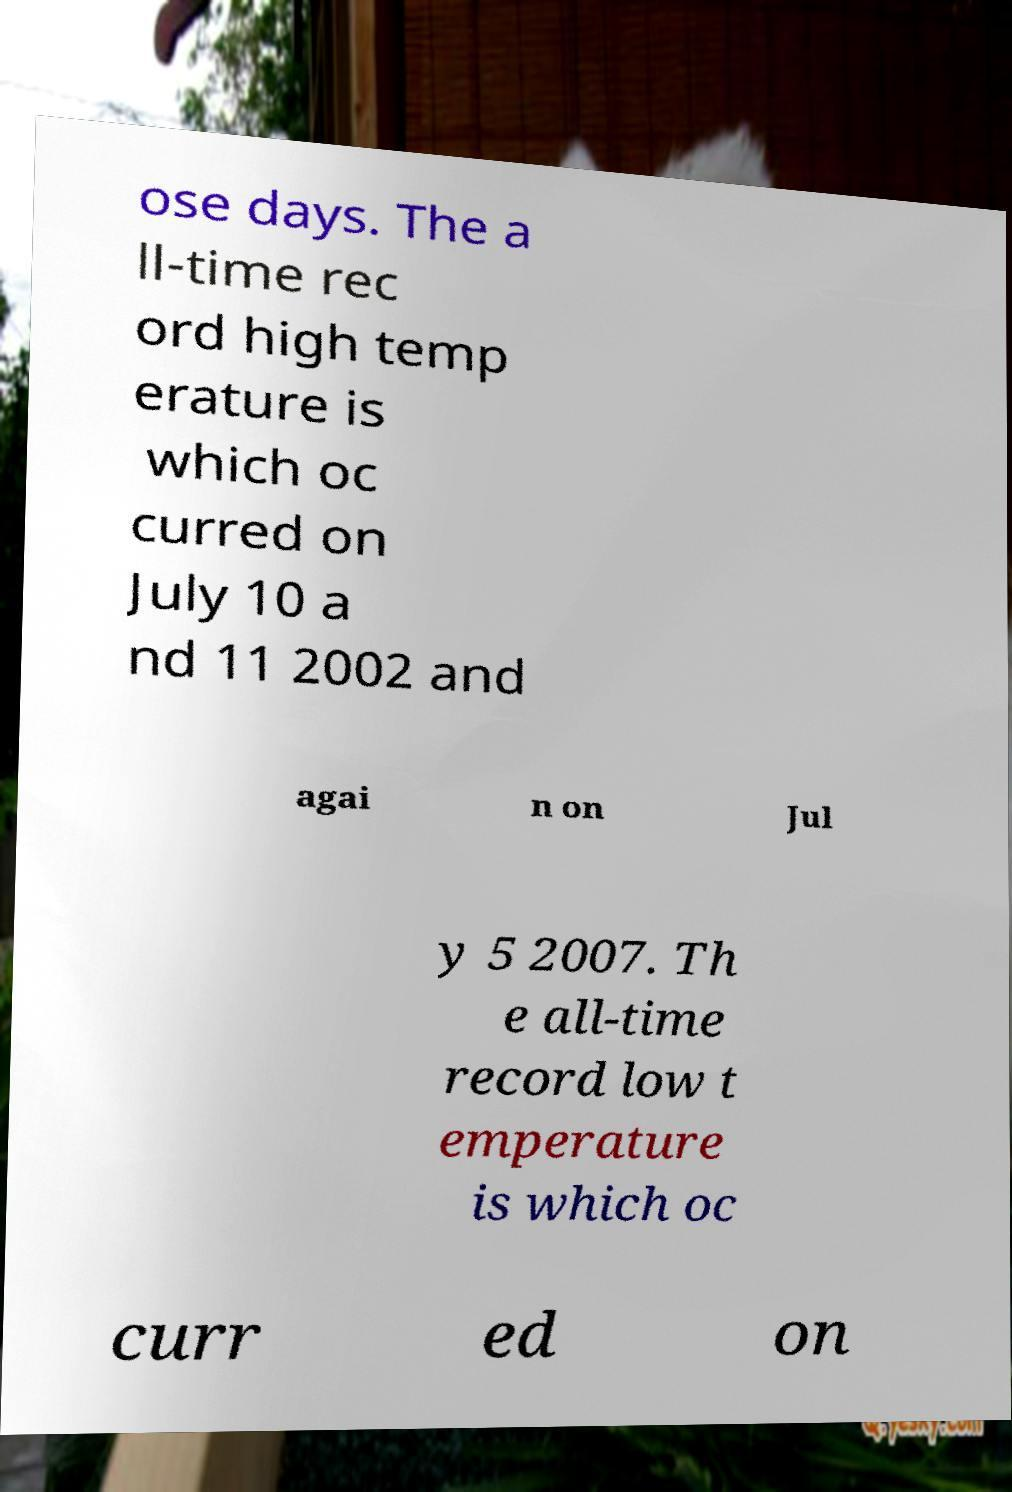There's text embedded in this image that I need extracted. Can you transcribe it verbatim? ose days. The a ll-time rec ord high temp erature is which oc curred on July 10 a nd 11 2002 and agai n on Jul y 5 2007. Th e all-time record low t emperature is which oc curr ed on 